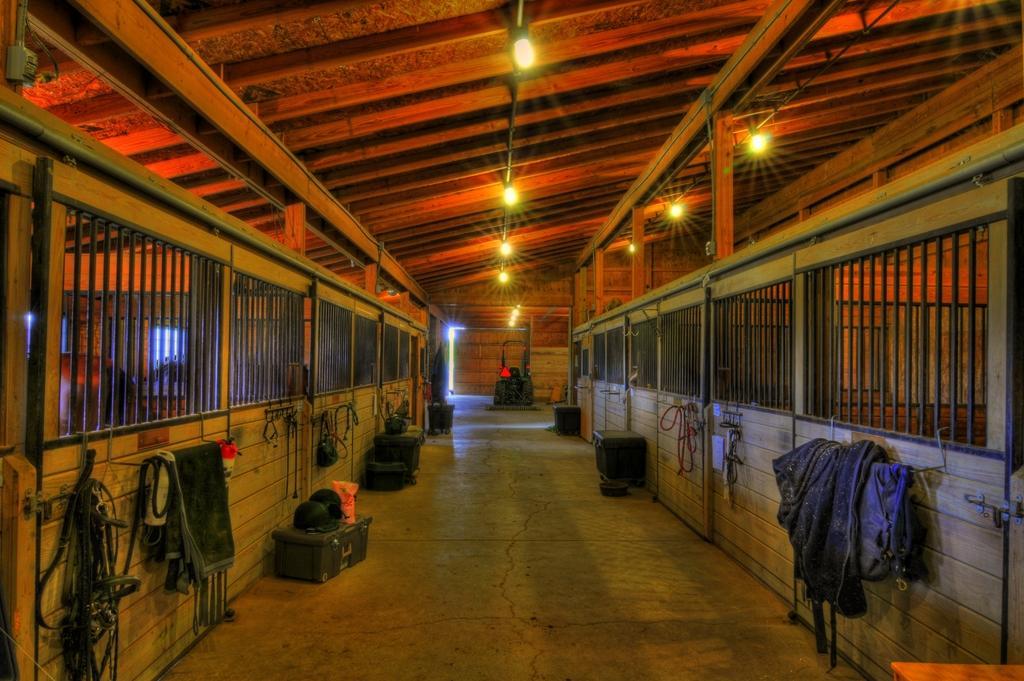Please provide a concise description of this image. In this image there is floor towards the bottom of the image, there is an object on the floor, there is an object towards the bottom of the image, there are wooden walls, there are objects on the wooden walls, there is the roof towards the top of the image, there are lights on the roof. 